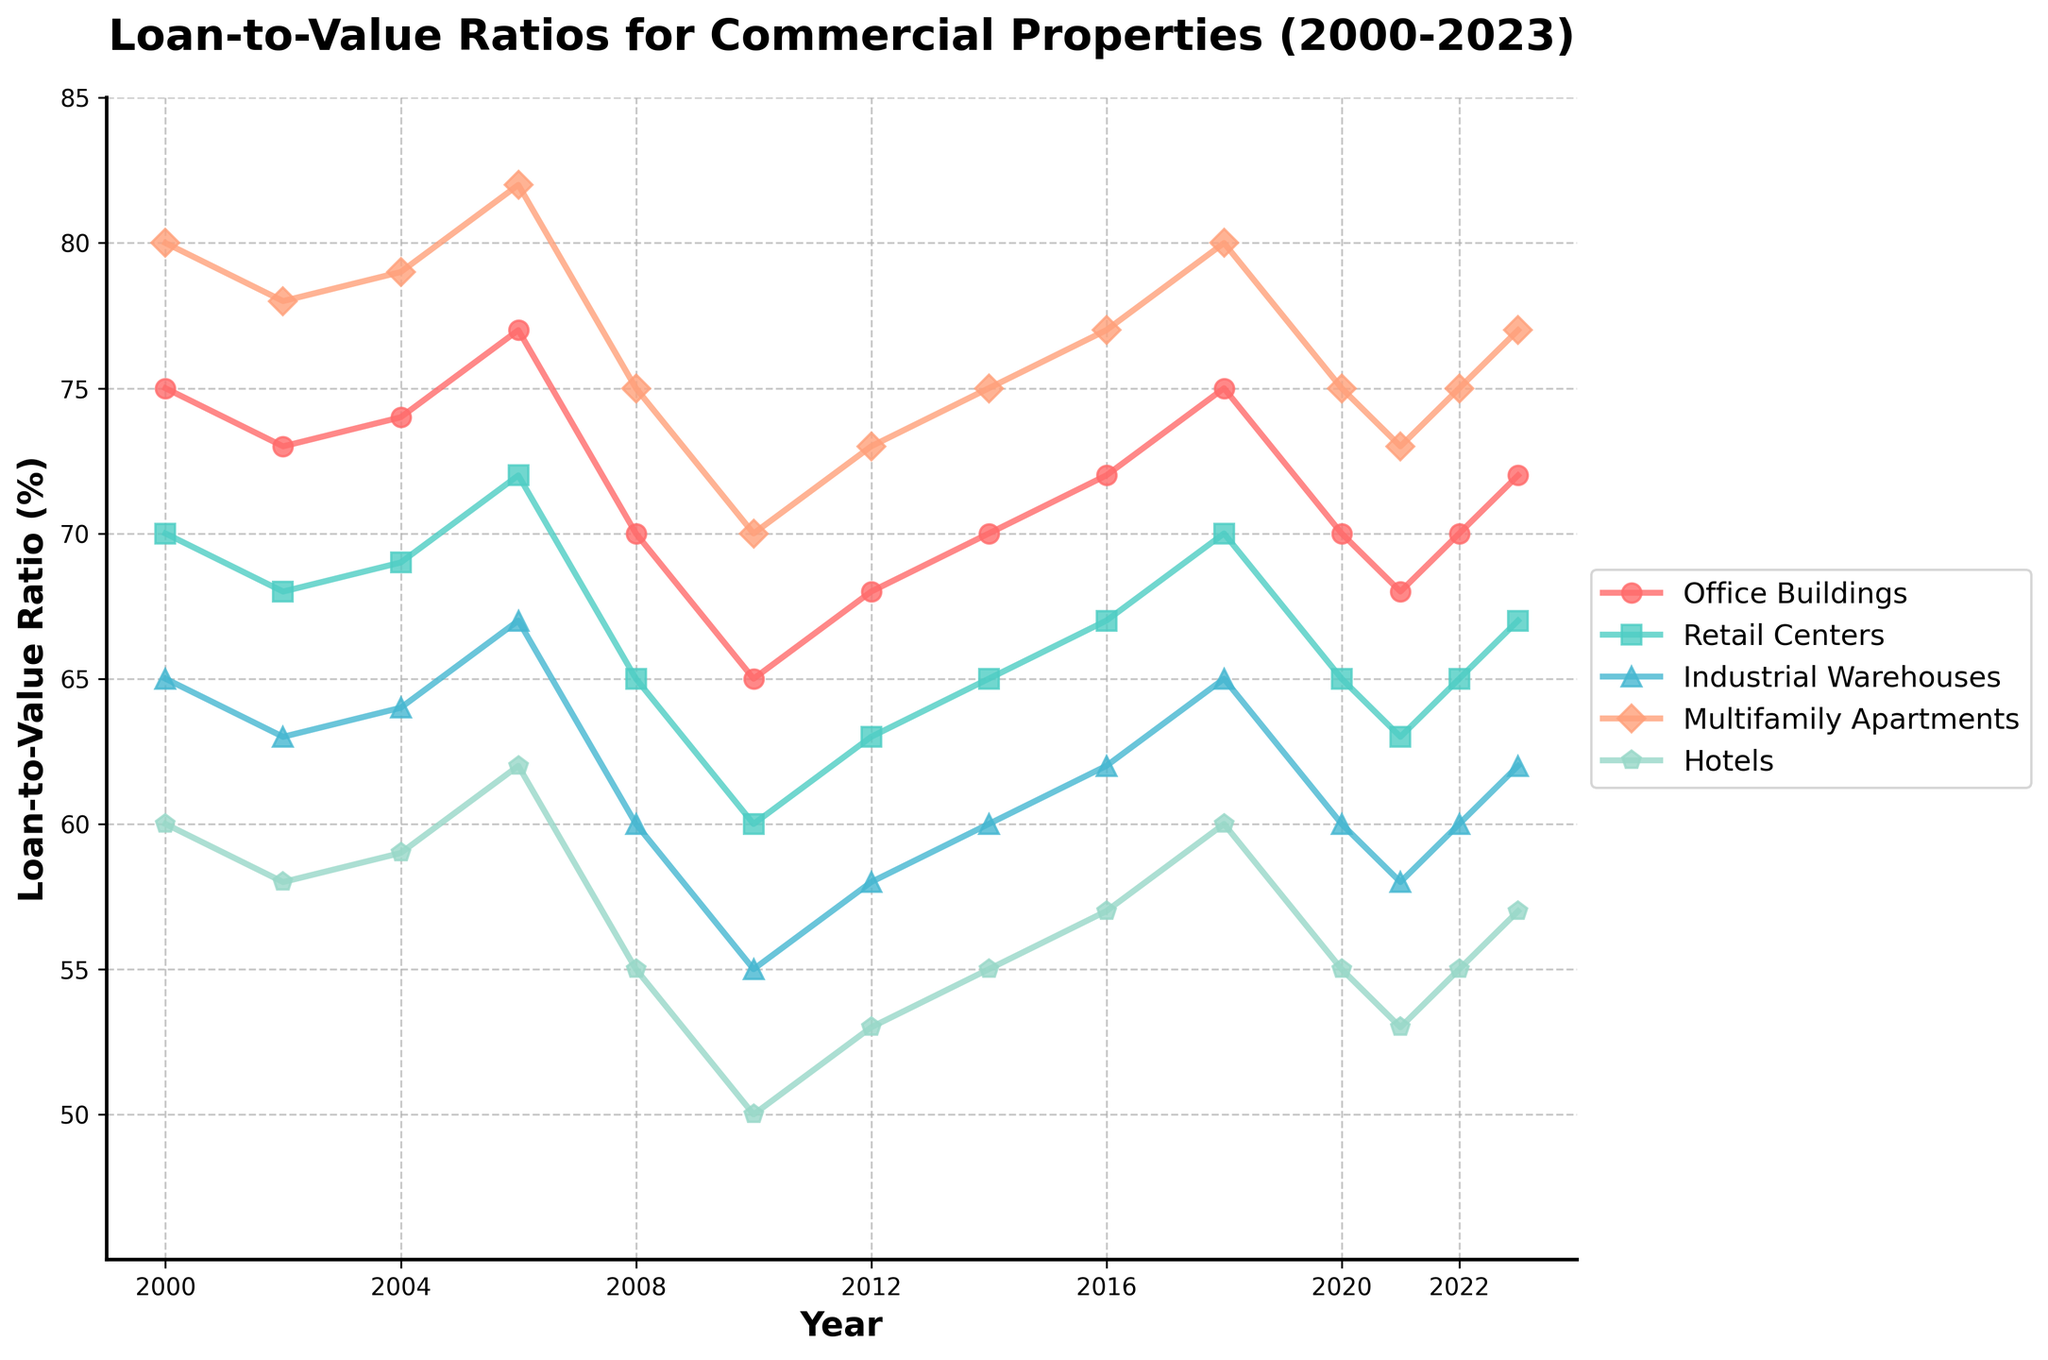What is the Loan-to-Value (LTV) ratio for Multifamily Apartments in 2010? Referring to the plot, locate the data point for Multifamily Apartments in the year 2010. The plot shows that the value is at 70.
Answer: 70 Which type of commercial property had the highest LTV ratio in 2023? In the year 2023, look at the data points of all property types and identify which one is the highest. The plot shows Multifamily Apartments had the highest ratio at 77.
Answer: Multifamily Apartments How did the LTV ratio for Office Buildings change from 2008 to 2010? Check the LTV ratio for Office Buildings in 2008 and compare it to 2010. In 2008, it was 70, and it decreased to 65 in 2010.
Answer: Decreased by 5 Which property type saw the largest decrease in LTV ratio during the 2008 financial crisis (2006-2008)? Compare the LTV ratios of all property types between 2006 and 2008. The plot shows Hotels had the largest decrease from 62 to 55, a drop of 7 points.
Answer: Hotels What is the average LTV ratio for Retail Centers between 2000 and 2023? To calculate the average, add up the LTV ratios for Retail Centers (70, 68, 69, 72, 65, 60, 63, 65, 67, 70, 65, 63, 65, 67) and divide by the number of data points (14). The average is (873 / 14) = 62.36.
Answer: 62.36 How did the LTV ratio for Industrial Warehouses change from 2000 to 2023? Check the LTV ratio for Industrial Warehouses in 2000 and 2023. In 2000, it was 65, and in 2023, it increased to 62.
Answer: Increased by 2 Which property type has the most stable (least variation) LTV ratio from 2000 to 2023? Examine the fluctuations of LTV ratios across the years for each property type. Multifamily Apartments show the most stability, with minor variations between 80 and 70.
Answer: Multifamily Apartments In which year did Hotels have their lowest LTV ratio, and what was it? By comparing the LTV ratios of Hotels across all years, the lowest value is in 2010 at 50.
Answer: 2010, 50 What is the difference between the highest and lowest LTV ratios for Office Buildings from 2000 to 2023? Identify the maximum and minimum LTV ratios for Office Buildings over the given years, which are 77 (2006) and 65 (2010). The difference is 77 - 65 = 12.
Answer: 12 In which year did Retail Centers and Industrial Warehouses have equal LTV ratios, and what was the value? Look for years where the LTV ratios for Retail Centers and Industrial Warehouses are the same. In 2004, both had an LTV ratio of 64.
Answer: 2004, 64 